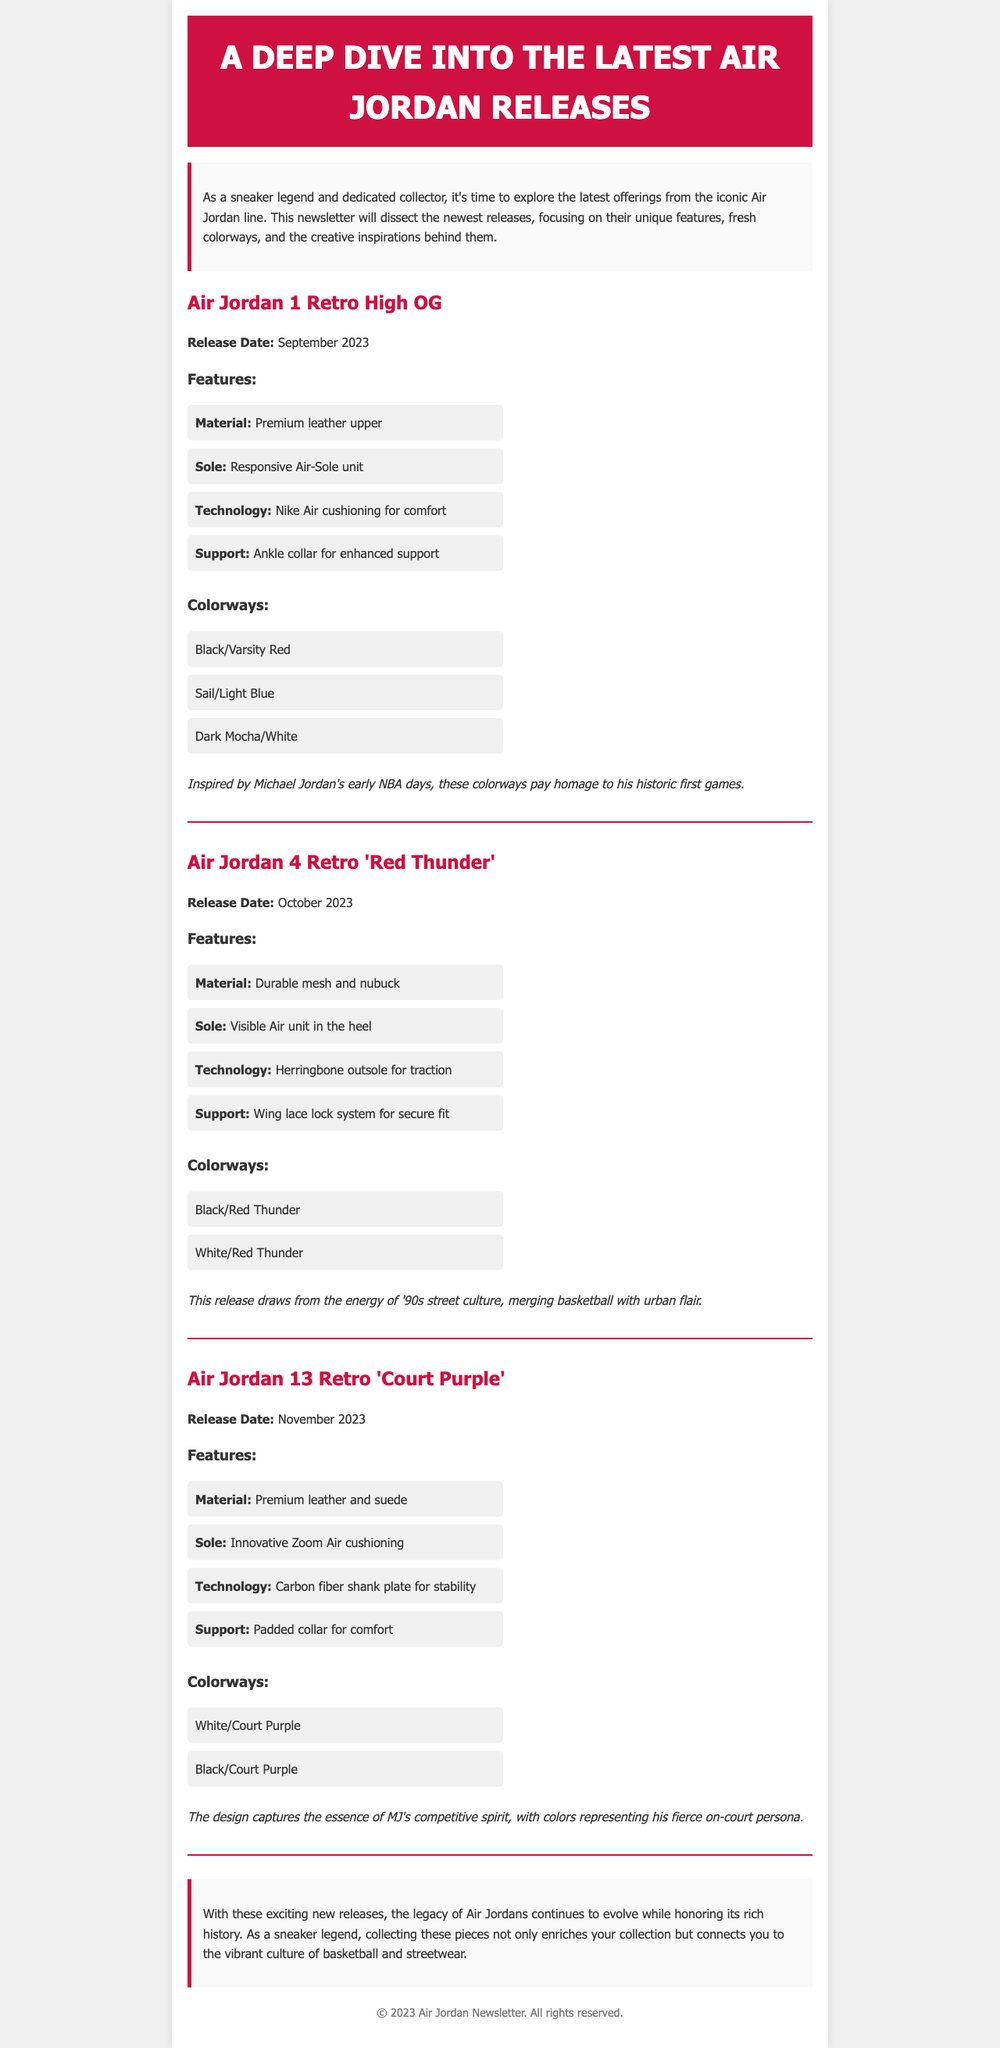What is the release date of Air Jordan 1 Retro High OG? The release date is explicitly mentioned in the document for each shoe, for Air Jordan 1 Retro High OG it is September 2023.
Answer: September 2023 What materials are used in Air Jordan 4 Retro 'Red Thunder'? The document lists the materials used for each release, for Air Jordan 4 Retro 'Red Thunder', it specifies durable mesh and nubuck.
Answer: Durable mesh and nubuck How many colorways does the Air Jordan 13 Retro 'Court Purple' have? The document provides the number of colorways listed for the Air Jordan 13 Retro 'Court Purple', which is mentioned in the colorways section.
Answer: 2 What is the inspiration behind the colorways of Air Jordan 1 Retro High OG? The document describes the inspiration for each model, for Air Jordan 1 Retro High OG, it mentions inspiration from Michael Jordan's early NBA days.
Answer: Michael Jordan's early NBA days Which Air Jordan model features a visible Air unit in the heel? The document explains the features of each model; for Air Jordan 4 Retro 'Red Thunder', it specifically mentions the visible Air unit.
Answer: Air Jordan 4 Retro 'Red Thunder' What is the padding feature in Air Jordan 13 Retro 'Court Purple'? The document describes the support features of Air Jordan 13 Retro 'Court Purple', highlighting the padded collar as a comfort feature.
Answer: Padded collar for comfort 